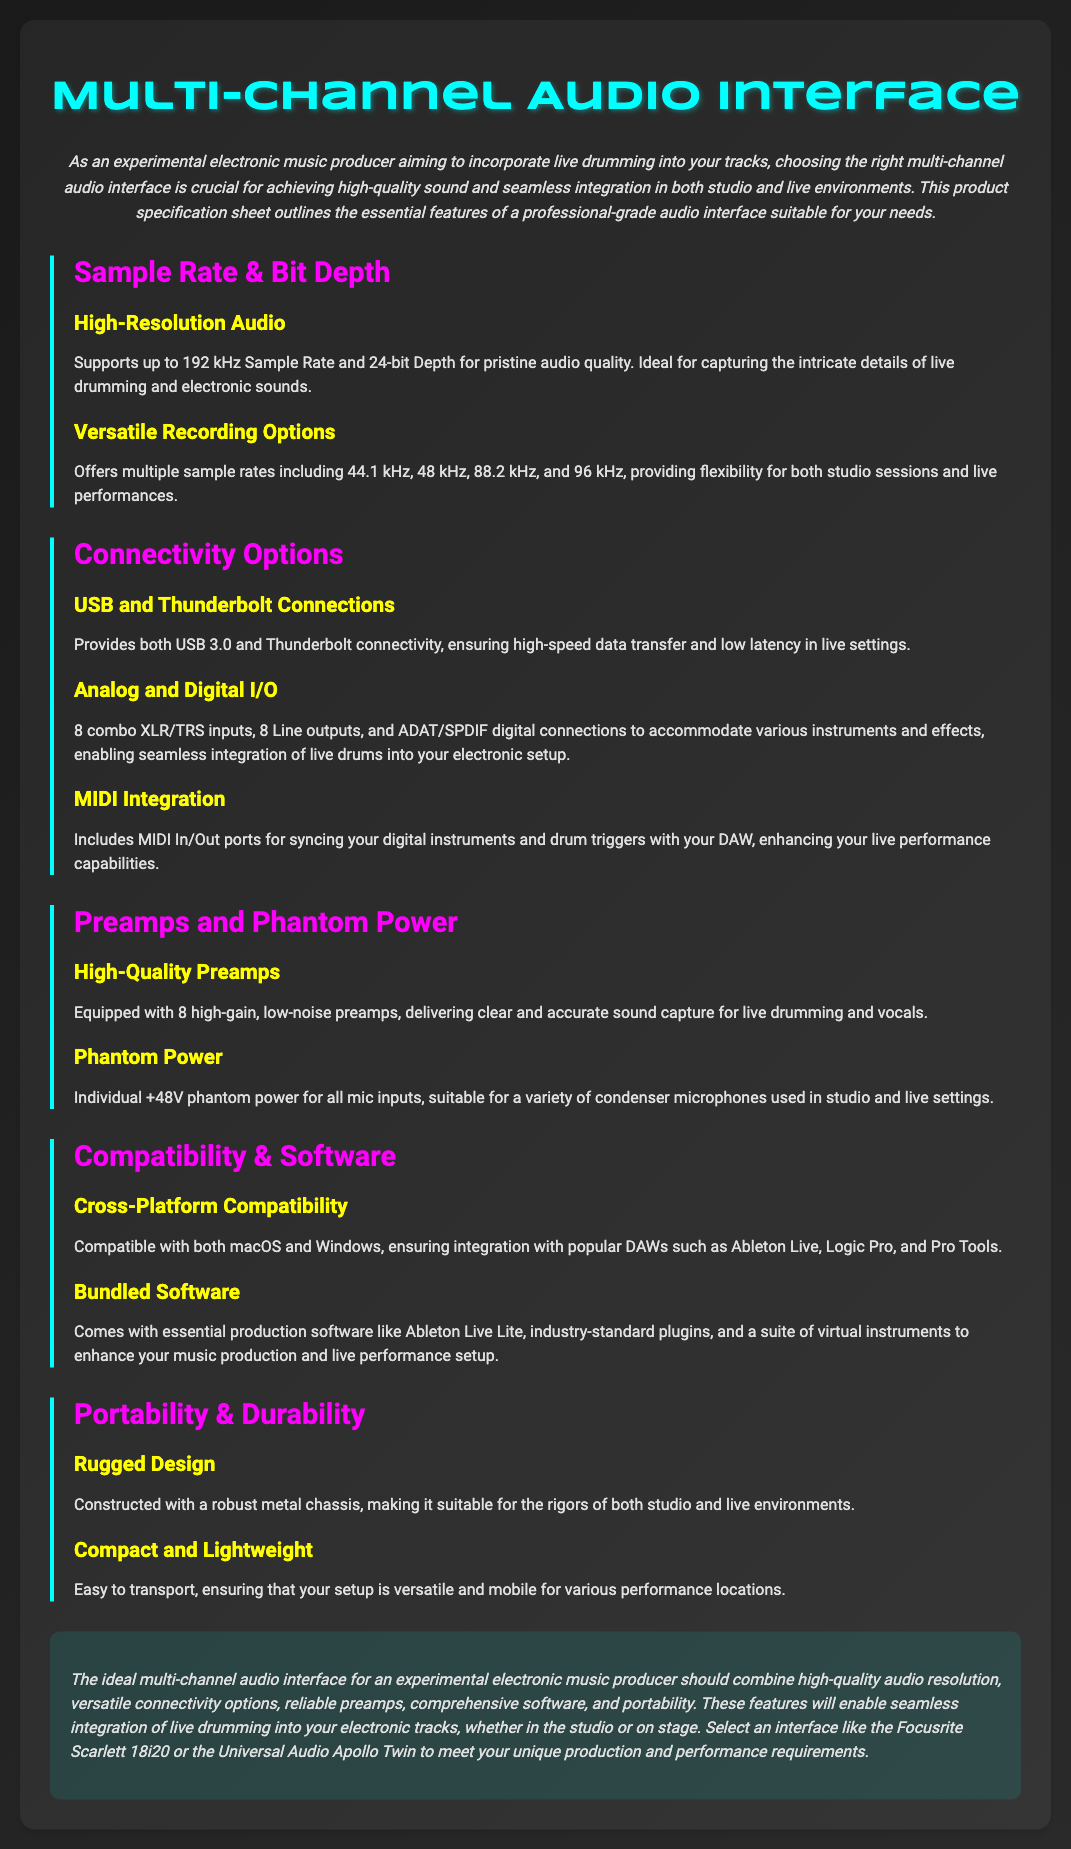What is the maximum sample rate supported? The document states that the maximum sample rate supported is up to 192 kHz.
Answer: 192 kHz What bit depth does the audio interface support? The specification sheet indicates that the audio interface supports a 24-bit depth.
Answer: 24-bit How many combo XLR/TRS inputs are available? It mentions that there are 8 combo XLR/TRS inputs available.
Answer: 8 What connectivity options are offered? The document lists USB 3.0 and Thunderbolt connectivity as options.
Answer: USB 3.0 and Thunderbolt What type of ports are included for MIDI integration? The document specifies that MIDI In/Out ports are included for MIDI integration.
Answer: MIDI In/Out ports What is the recommended audio interface mentioned? The document suggests the Focusrite Scarlett 18i20 or the Universal Audio Apollo Twin.
Answer: Focusrite Scarlett 18i20 or Universal Audio Apollo Twin Which operating systems are compatible with the audio interface? The specification sheet states that it is compatible with both macOS and Windows.
Answer: macOS and Windows What is the purpose of individual +48V phantom power? It is suitable for a variety of condenser microphones used in studio and live settings.
Answer: For condenser microphones How is the build of the audio interface described? The document describes it as having a robust metal chassis for durability.
Answer: Robust metal chassis What type of bundled software is included? Essential production software like Ableton Live Lite and virtual instruments are included.
Answer: Ableton Live Lite and virtual instruments 